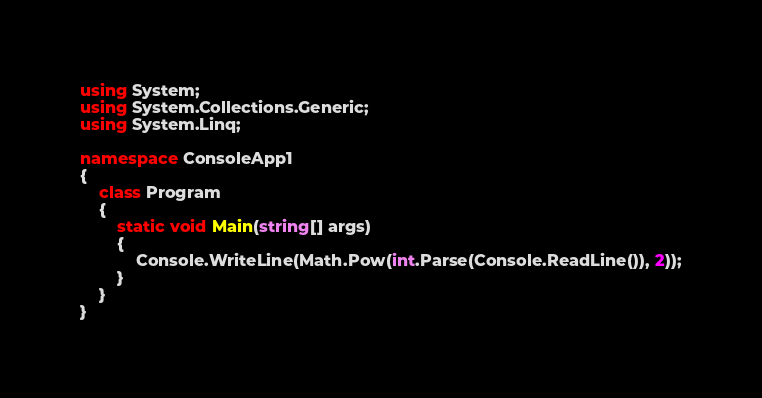<code> <loc_0><loc_0><loc_500><loc_500><_C#_>using System;
using System.Collections.Generic;
using System.Linq;

namespace ConsoleApp1
{
    class Program
    {
        static void Main(string[] args)
        {
            Console.WriteLine(Math.Pow(int.Parse(Console.ReadLine()), 2));
        }
    }
}</code> 